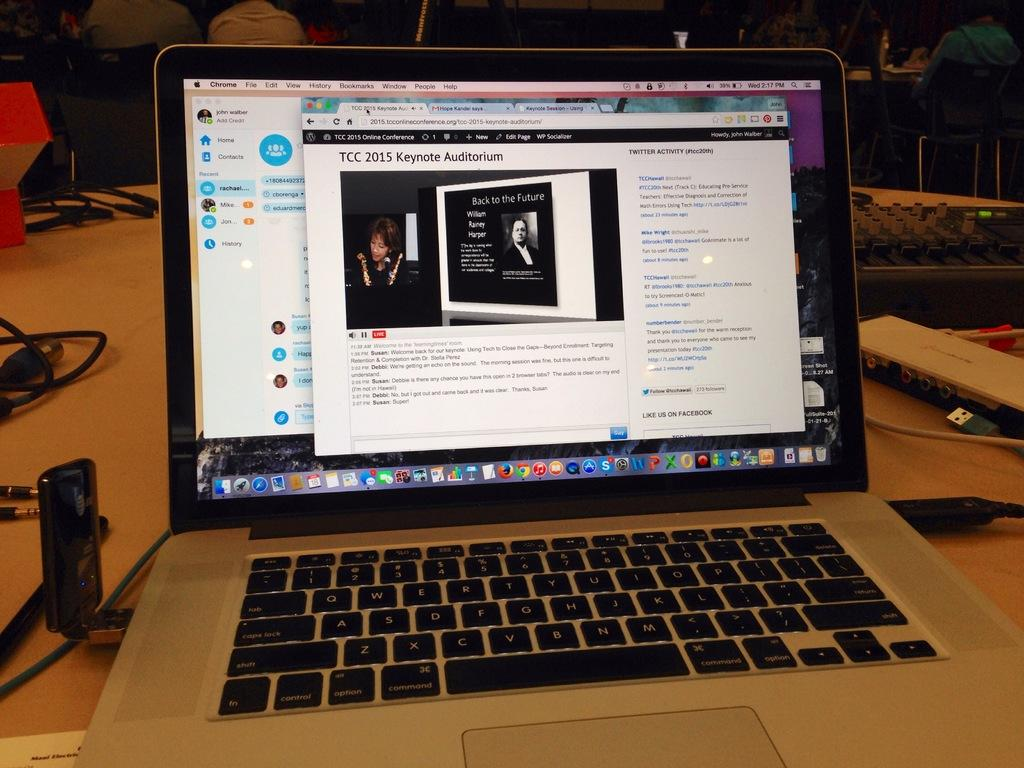<image>
Summarize the visual content of the image. A computer screen reads TCC 2015 Keynote Auditorium." 